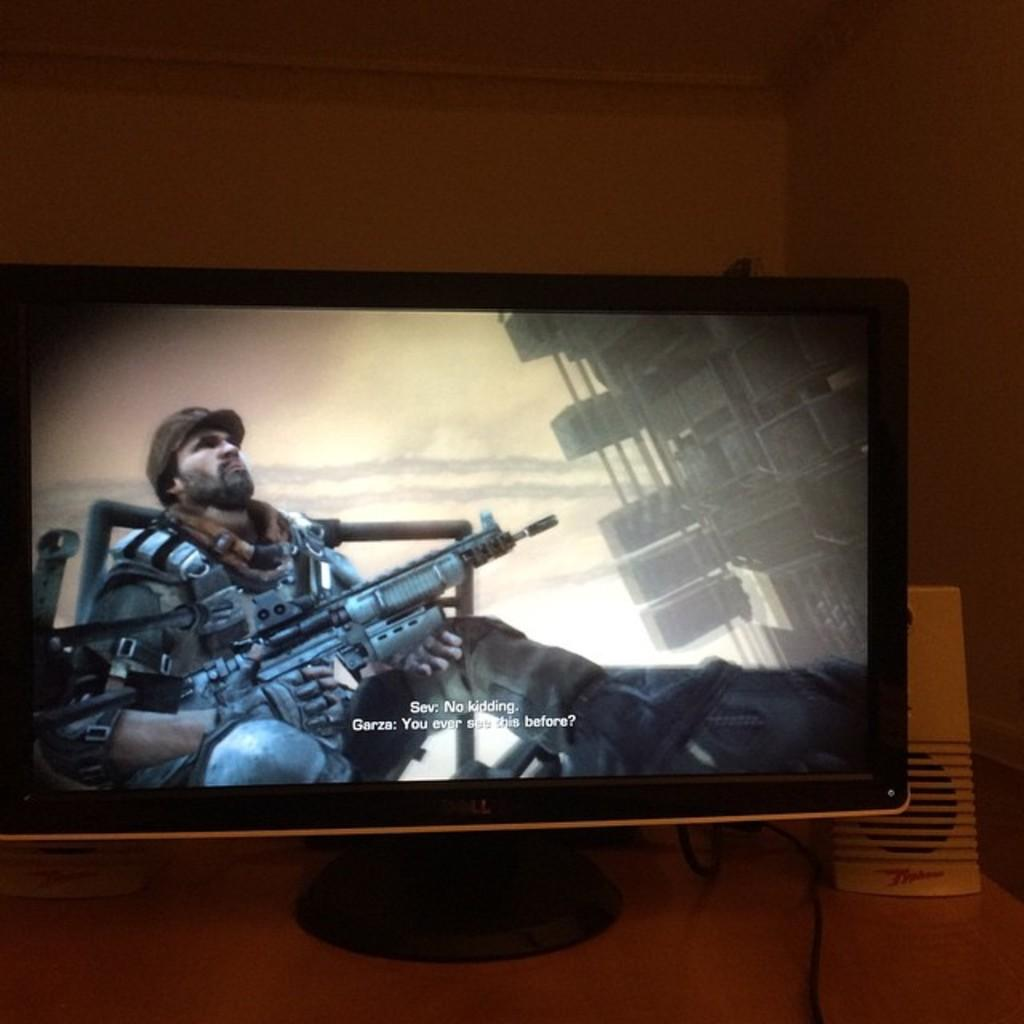What is the main object in the image? There is a screen in the image. What else can be seen in the image besides the screen? There is a wire and white-colored objects visible in the image. What is the background of the image? There is a wall in the image. What type of print can be seen on the sidewalk in the image? There is no sidewalk present in the image, so it is not possible to determine if there is any print on it. 